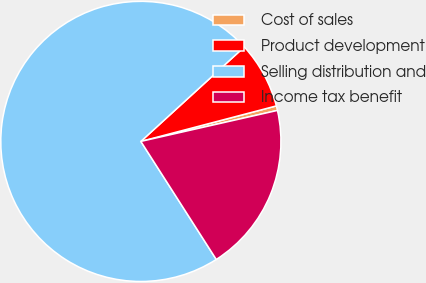Convert chart. <chart><loc_0><loc_0><loc_500><loc_500><pie_chart><fcel>Cost of sales<fcel>Product development<fcel>Selling distribution and<fcel>Income tax benefit<nl><fcel>0.53%<fcel>7.7%<fcel>72.27%<fcel>19.5%<nl></chart> 